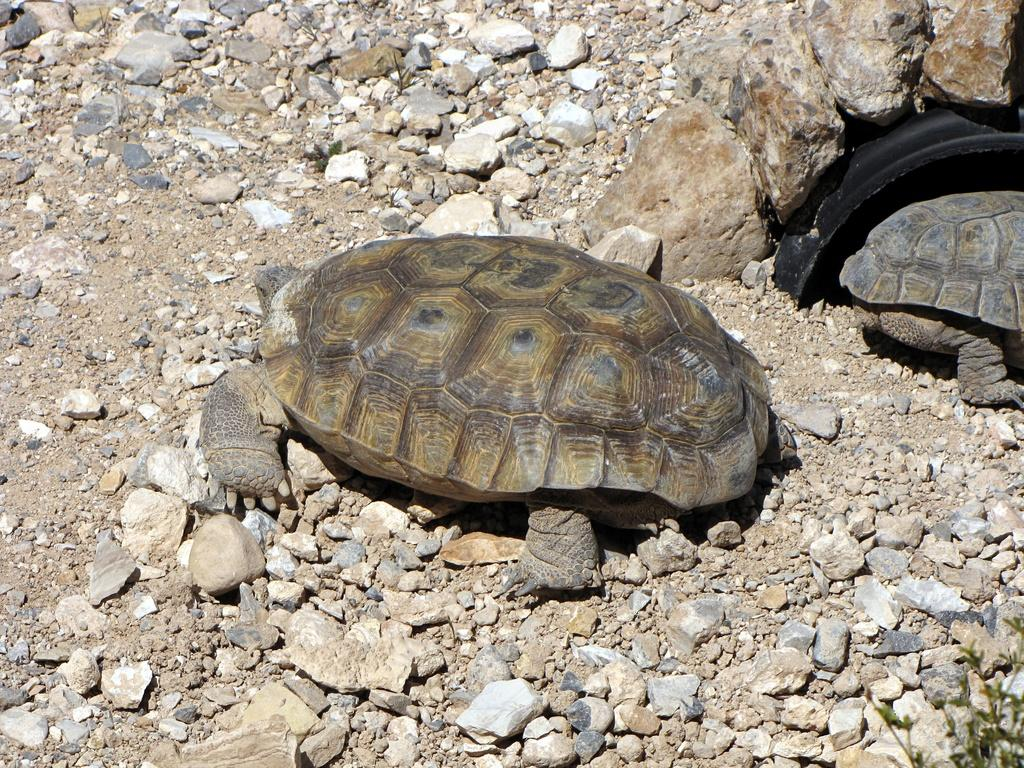What type of animals are present in the image? There are turtles in the image. What can be seen at the bottom of the image? There are stones at the bottom of the image. How many passengers are in the carriage in the image? There is no carriage present in the image; it features turtles and stones. What type of hall can be seen in the image? There is no hall present in the image; it features turtles and stones. 